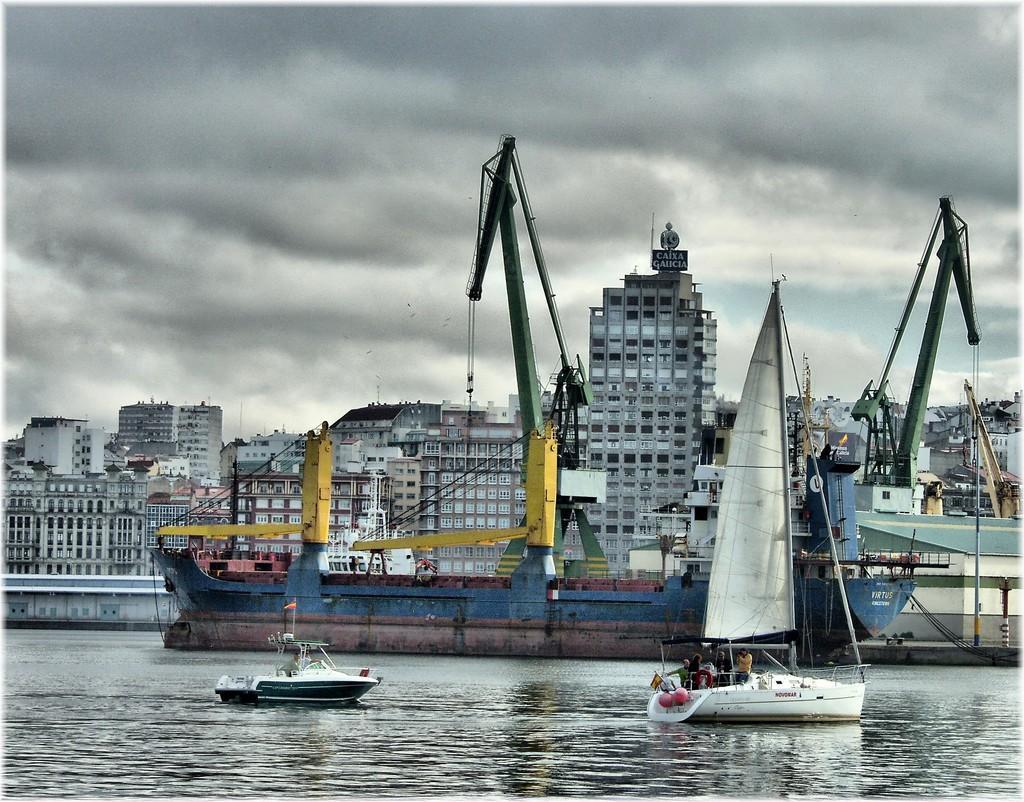How would you summarize this image in a sentence or two? In this image there is a ship and there are two boats sailing in the water. In the background there are many buildings. There is a cloudy sky at the top. 